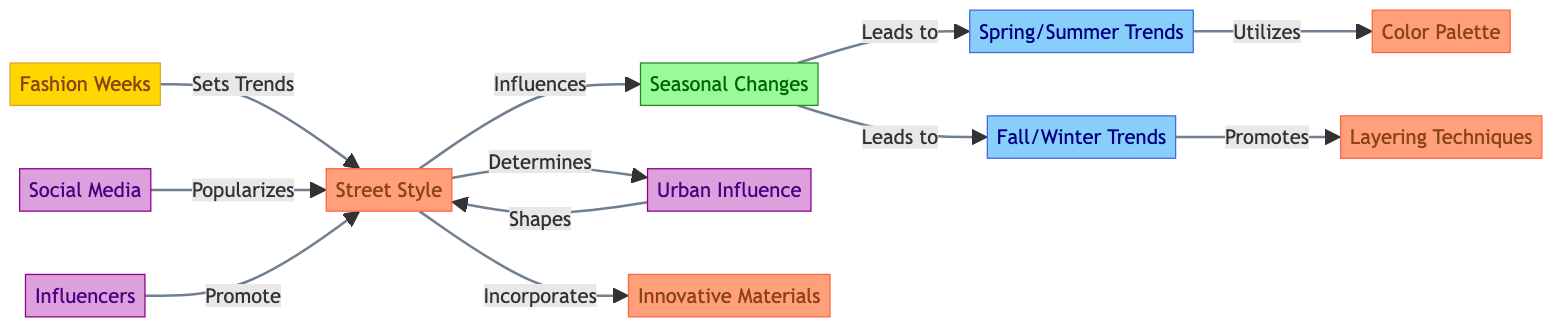What is the total number of nodes in the diagram? The diagram contains 11 nodes, which are listed under the "nodes" section of the data provided.
Answer: 11 Which node leads to Spring/Summer Trends? The "Seasonal Changes" node has an edge pointing to the "Spring/Summer Trends" node, indicating it leads to this trend.
Answer: Seasonal Changes How many influences are connected directly to Street Style? There are three influences connected to Street Style: "Urban Influence," "Social Media," and "Influencers," as shown in the edges section.
Answer: 3 What trend is promoted by Fall/Winter? The "Fall/Winter" node promotes "Layering Techniques," as indicated by the edge connecting these two nodes.
Answer: Layering Techniques What is the role of Fashion Weeks in the diagram? The "Fashion Weeks" node sets trends for "Street Style," demonstrating its influence in the fashion trend cycle.
Answer: Sets Trends Which factors lead to seasonal changes? The "Street Style" node influences "Seasonal Changes" directly, indicating its role in the evolution of fashion trends.
Answer: Street Style What type of techniques does Spring/Summer utilize? The "Spring/Summer Trends" node utilizes a "Color Palette," highlighting the specific design elements of this seasonal trend.
Answer: Color Palette How does Urban Influence relate to Street Style? The "Urban Influence" node shapes and determines the style of Street Style, as shown by the bidirectional edges between these nodes.
Answer: Shapes Which innovative aspect is incorporated into Street Style? The "Street Style" node incorporates "Innovative Materials," illustrating its adaptive nature in modern fashion trends.
Answer: Innovative Materials 